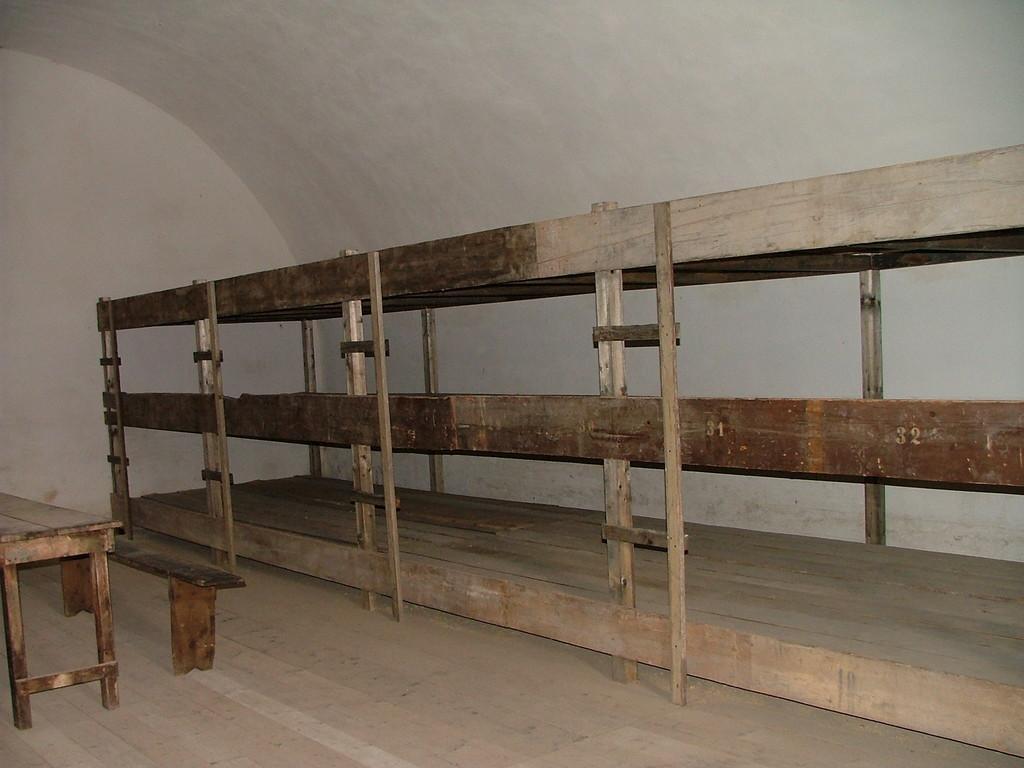Please provide a concise description of this image. In this picture we can see benches and wooden railing in the room. 